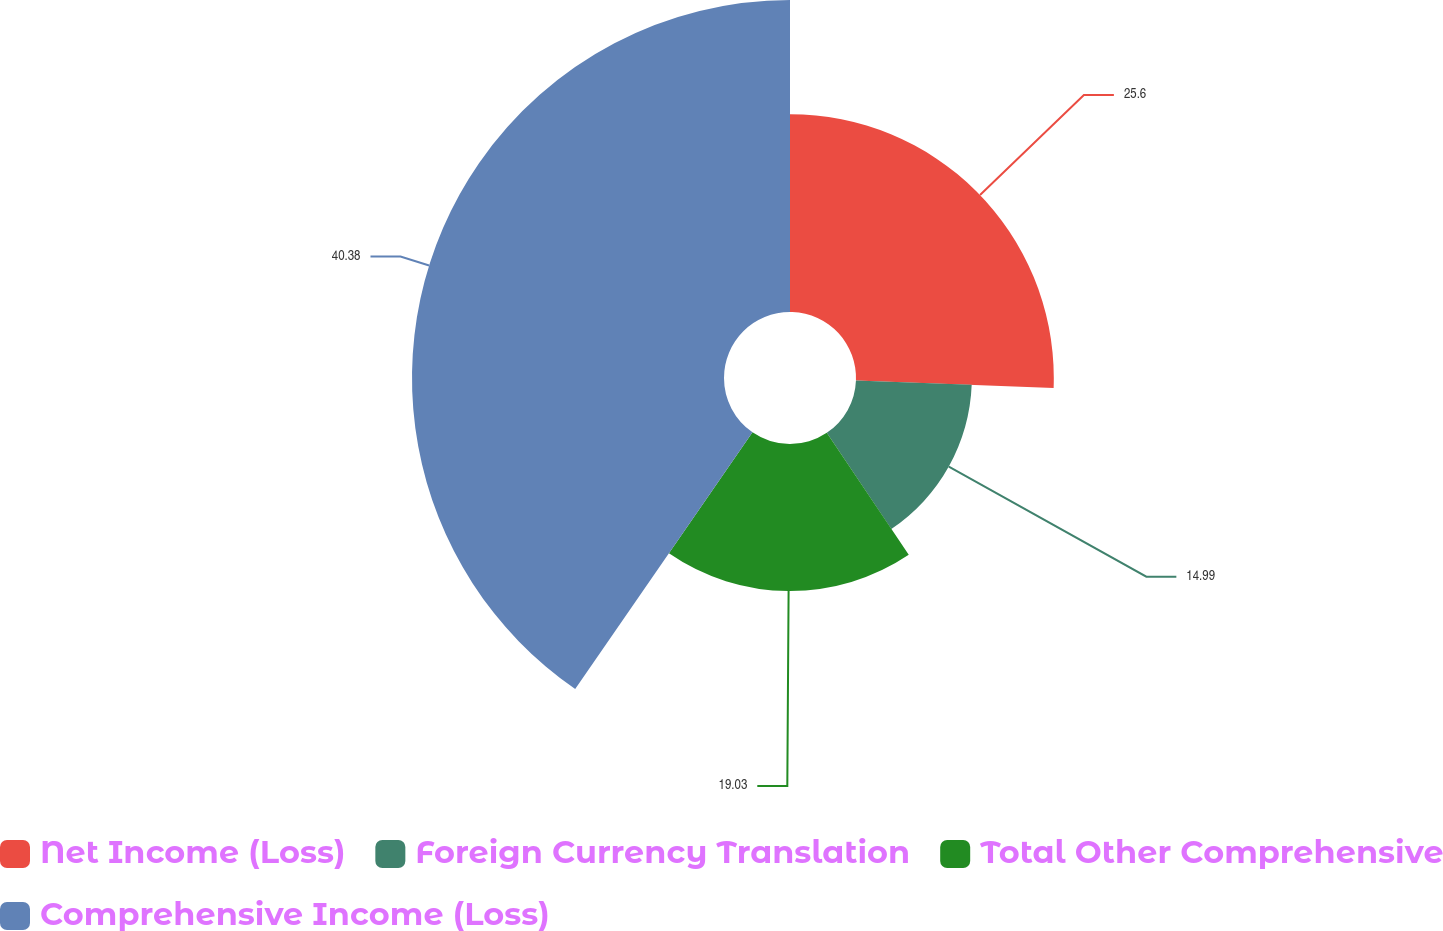<chart> <loc_0><loc_0><loc_500><loc_500><pie_chart><fcel>Net Income (Loss)<fcel>Foreign Currency Translation<fcel>Total Other Comprehensive<fcel>Comprehensive Income (Loss)<nl><fcel>25.6%<fcel>14.99%<fcel>19.03%<fcel>40.38%<nl></chart> 